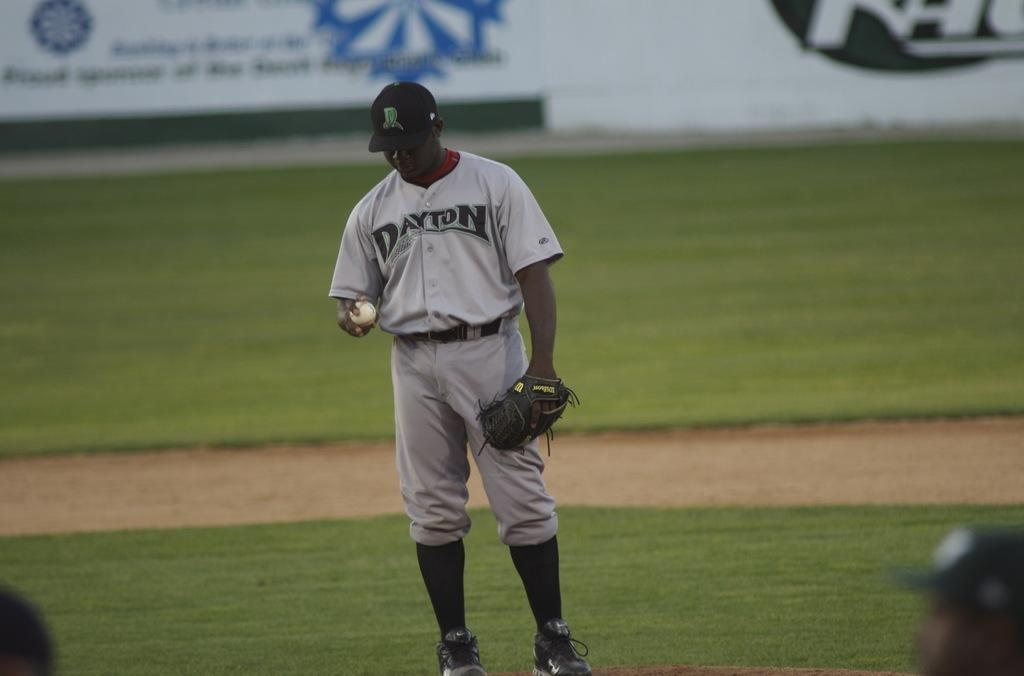<image>
Describe the image concisely. Baseball player wearing a gray jersey that says Dayton on it. 